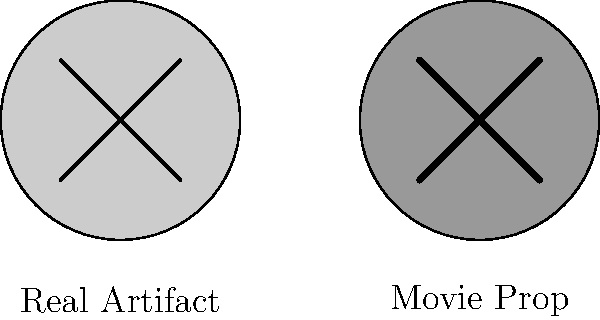In the image above, compare the real historical artifact (left) with its movie prop counterpart (right). What key difference can be observed, and how might this reflect the common issues with historical accuracy in 'based on true story' films? 1. Observe the two circular objects representing a historical artifact and its movie prop counterpart.

2. Note the key differences:
   a) The real artifact (left) has thinner lines forming the 'X' shape.
   b) The movie prop (right) has noticeably thicker lines forming the 'X' shape.
   c) The movie prop is slightly darker in color.

3. These differences reflect common issues with historical accuracy in 'based on true story' films:
   a) Exaggeration: The thicker lines on the movie prop suggest an emphasis on visual impact over historical accuracy.
   b) Dramatization: The darker color of the prop may indicate an attempt to make the object appear more dramatic or significant than it actually was.

4. This visual representation demonstrates how filmmakers often take artistic liberties with historical artifacts:
   a) To make them more visually striking for the audience.
   b) To enhance the dramatic effect of the prop in the film.

5. Such alterations, while seemingly minor, can lead to misconceptions about historical objects and events:
   a) Viewers may form inaccurate impressions of the actual historical artifacts.
   b) These inaccuracies can contribute to a skewed understanding of history.

6. This example highlights the importance of critical analysis when viewing 'based on true story' films:
   a) Recognizing that visual representations may be altered for dramatic effect.
   b) Understanding that these alterations can impact our perception of historical events and objects.
Answer: Exaggerated features in movie prop for visual impact, compromising historical accuracy. 